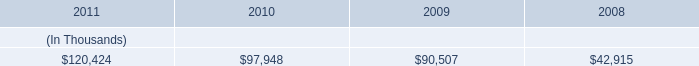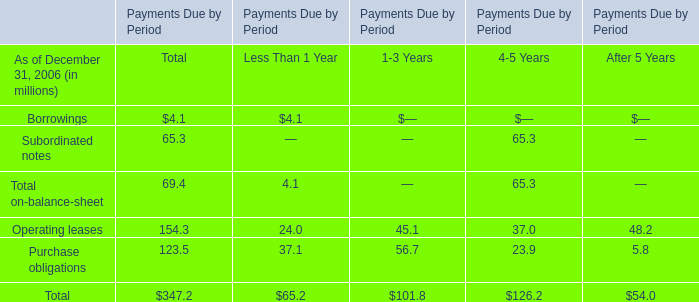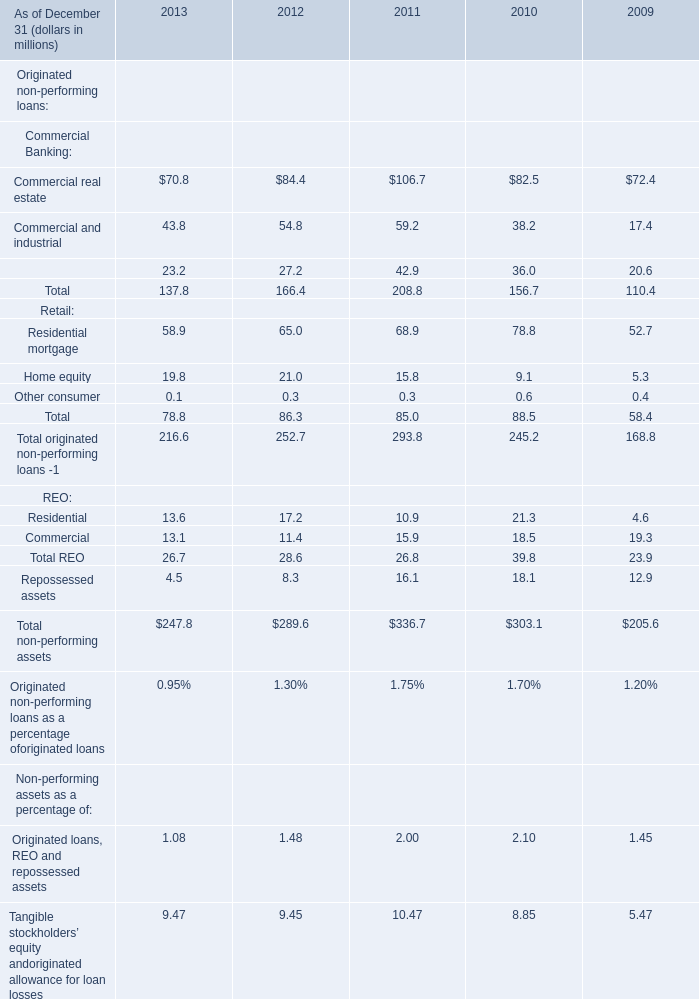What's the total value of all retail that are smaller than 60 in 2011? (in million) 
Computations: (15.8 + 0.3)
Answer: 16.1. 